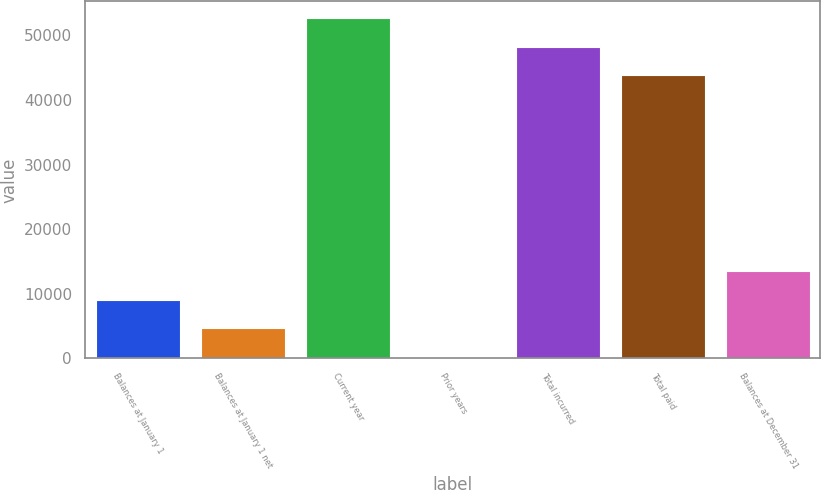Convert chart to OTSL. <chart><loc_0><loc_0><loc_500><loc_500><bar_chart><fcel>Balances at January 1<fcel>Balances at January 1 net<fcel>Current year<fcel>Prior years<fcel>Total incurred<fcel>Total paid<fcel>Balances at December 31<nl><fcel>9068.2<fcel>4652.1<fcel>52675.2<fcel>236<fcel>48259.1<fcel>43843<fcel>13484.3<nl></chart> 